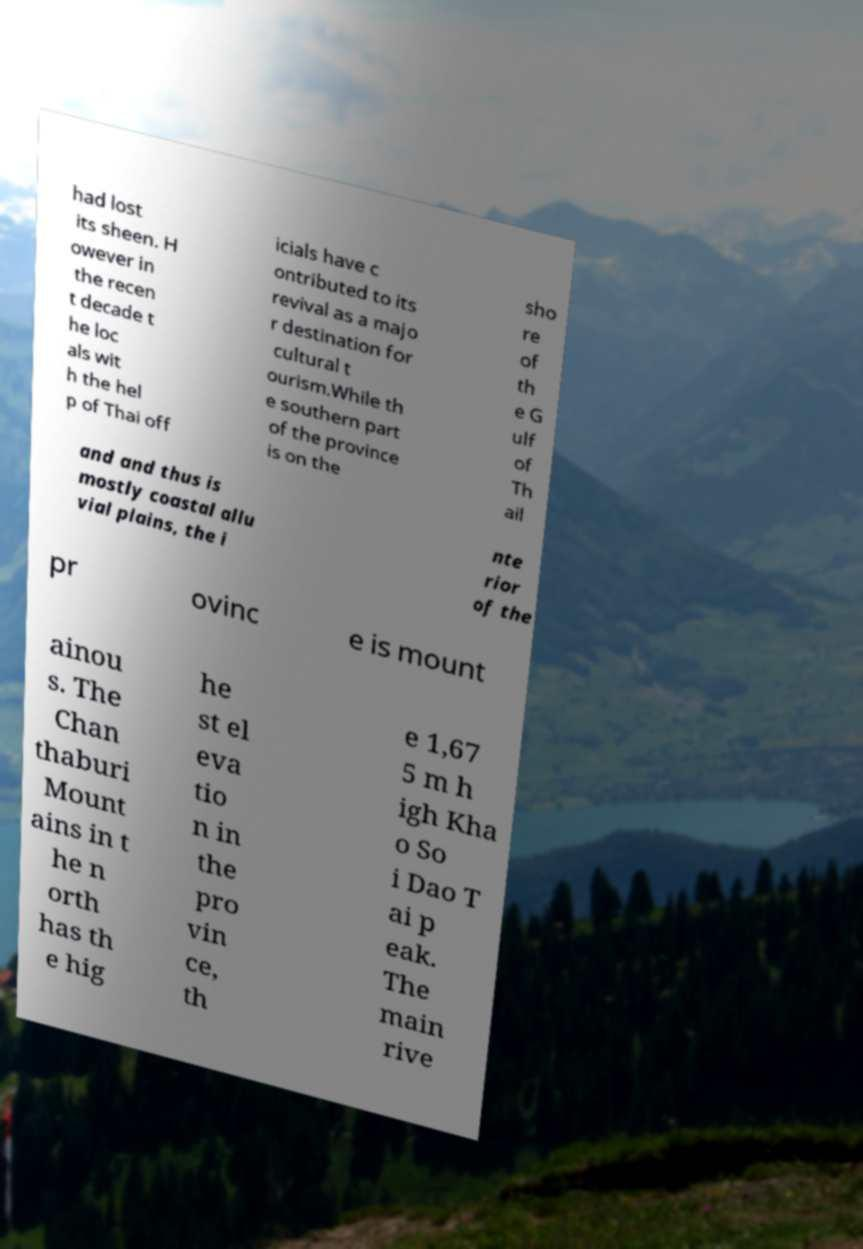Could you assist in decoding the text presented in this image and type it out clearly? had lost its sheen. H owever in the recen t decade t he loc als wit h the hel p of Thai off icials have c ontributed to its revival as a majo r destination for cultural t ourism.While th e southern part of the province is on the sho re of th e G ulf of Th ail and and thus is mostly coastal allu vial plains, the i nte rior of the pr ovinc e is mount ainou s. The Chan thaburi Mount ains in t he n orth has th e hig he st el eva tio n in the pro vin ce, th e 1,67 5 m h igh Kha o So i Dao T ai p eak. The main rive 